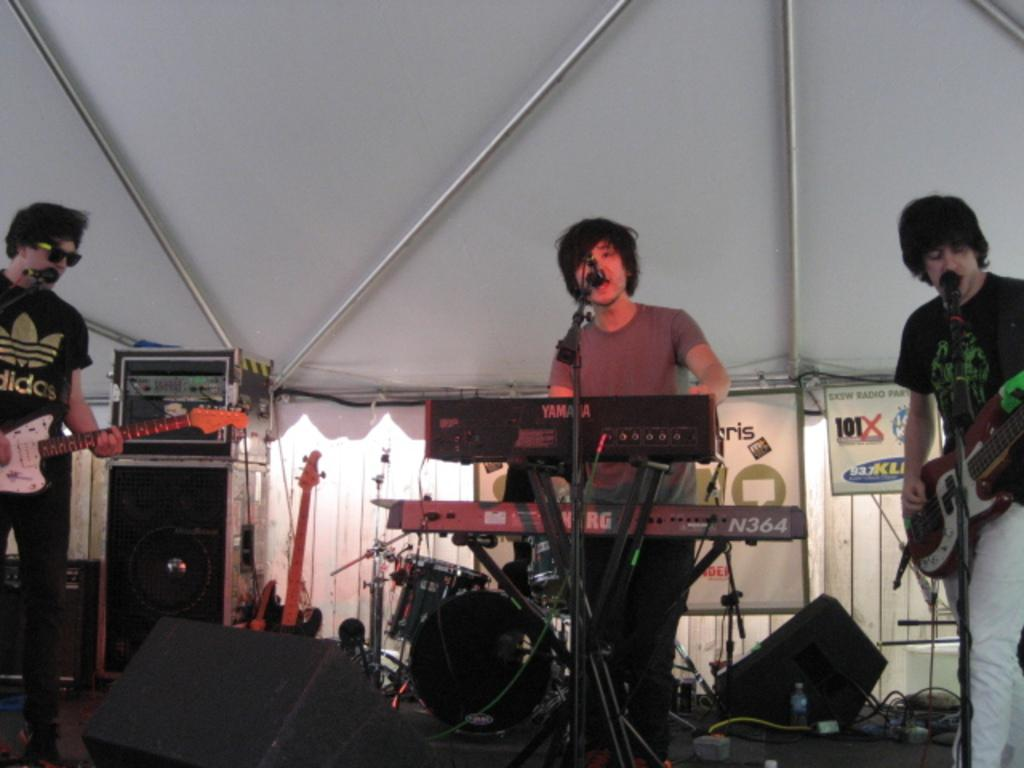How many people are on the stage during the performance? There are 3 people on the stage. What are the people on the stage doing? The people are performing. What type of performance is taking place? The performance involves playing musical instruments. Is there any vocal component to the performance? Yes, at least one person is singing on a microphone. How many bikes are being ridden by the performers on stage? There is no mention of bikes in the image or the provided facts, so it cannot be determined if any performers are riding bikes. 